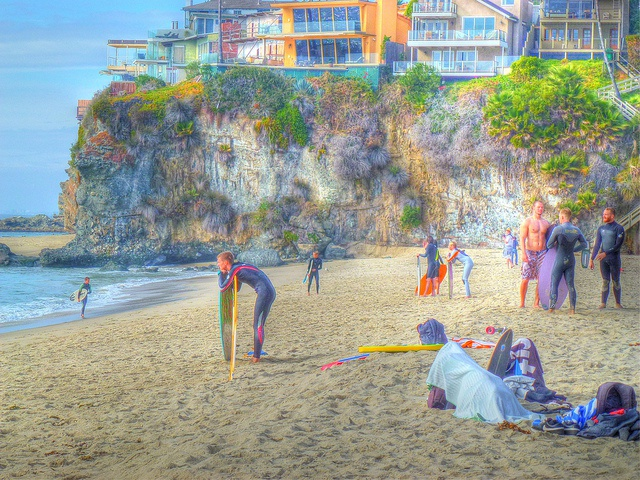Describe the objects in this image and their specific colors. I can see people in lightblue, gray, and brown tones, people in lightblue, gray, navy, and darkblue tones, people in lightblue, navy, gray, and black tones, people in lightblue, lightpink, tan, and salmon tones, and backpack in lightblue, navy, purple, black, and gray tones in this image. 